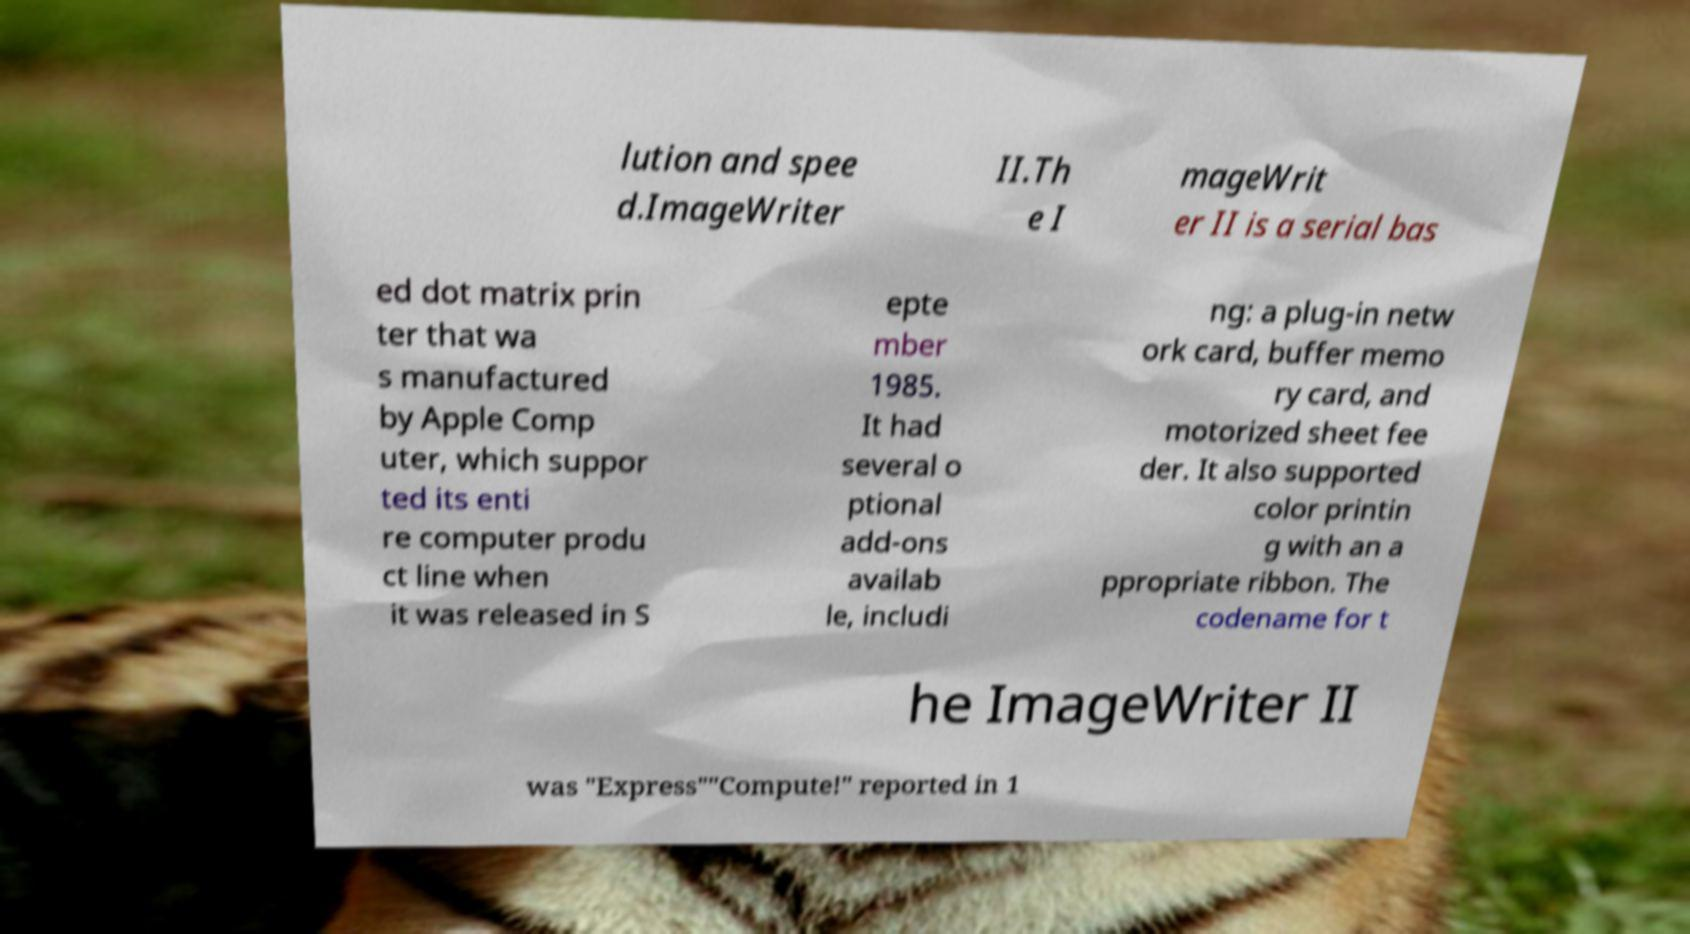Can you read and provide the text displayed in the image?This photo seems to have some interesting text. Can you extract and type it out for me? lution and spee d.ImageWriter II.Th e I mageWrit er II is a serial bas ed dot matrix prin ter that wa s manufactured by Apple Comp uter, which suppor ted its enti re computer produ ct line when it was released in S epte mber 1985. It had several o ptional add-ons availab le, includi ng: a plug-in netw ork card, buffer memo ry card, and motorized sheet fee der. It also supported color printin g with an a ppropriate ribbon. The codename for t he ImageWriter II was "Express""Compute!" reported in 1 